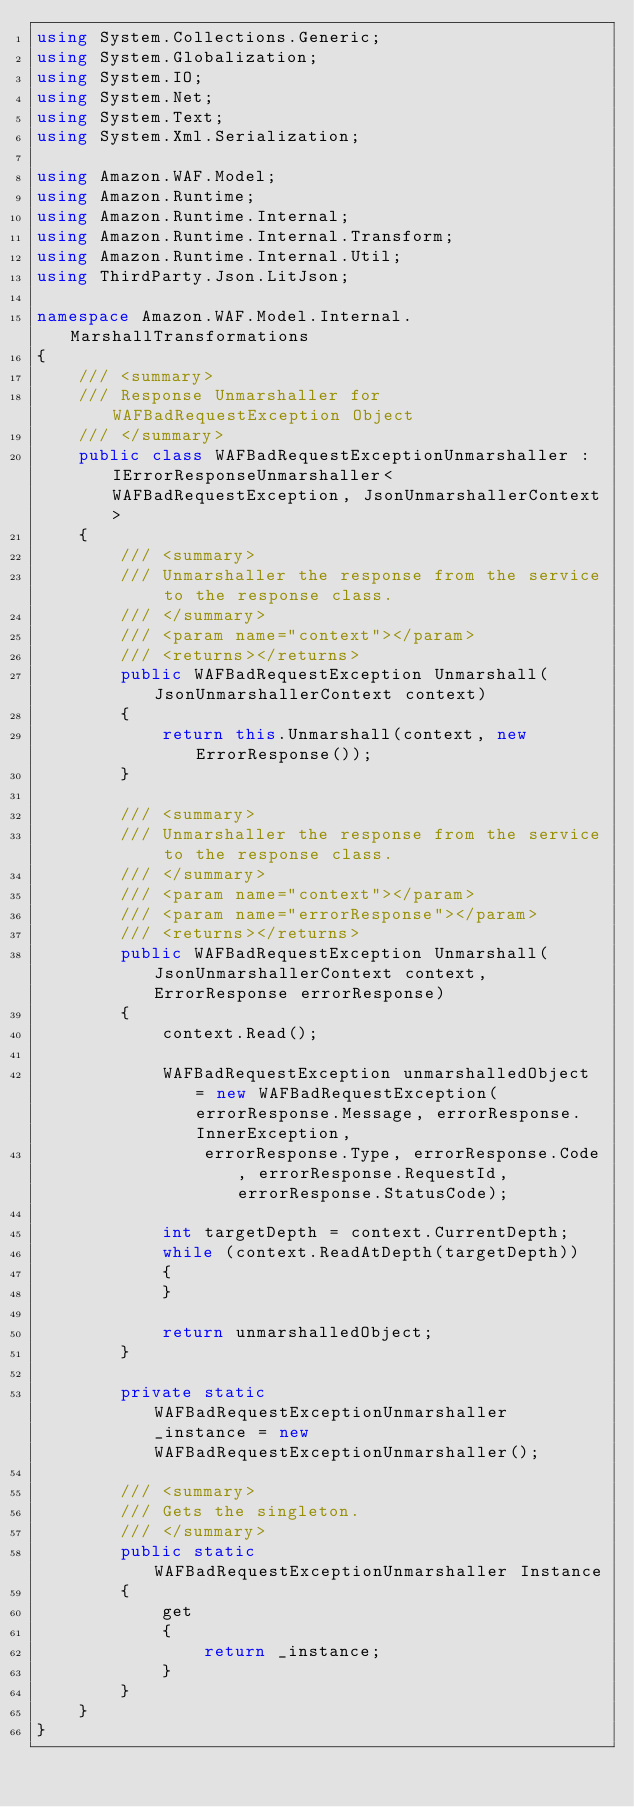Convert code to text. <code><loc_0><loc_0><loc_500><loc_500><_C#_>using System.Collections.Generic;
using System.Globalization;
using System.IO;
using System.Net;
using System.Text;
using System.Xml.Serialization;

using Amazon.WAF.Model;
using Amazon.Runtime;
using Amazon.Runtime.Internal;
using Amazon.Runtime.Internal.Transform;
using Amazon.Runtime.Internal.Util;
using ThirdParty.Json.LitJson;

namespace Amazon.WAF.Model.Internal.MarshallTransformations
{
    /// <summary>
    /// Response Unmarshaller for WAFBadRequestException Object
    /// </summary>  
    public class WAFBadRequestExceptionUnmarshaller : IErrorResponseUnmarshaller<WAFBadRequestException, JsonUnmarshallerContext>
    {
        /// <summary>
        /// Unmarshaller the response from the service to the response class.
        /// </summary>  
        /// <param name="context"></param>
        /// <returns></returns>
        public WAFBadRequestException Unmarshall(JsonUnmarshallerContext context)
        {
            return this.Unmarshall(context, new ErrorResponse());
        }

        /// <summary>
        /// Unmarshaller the response from the service to the response class.
        /// </summary>  
        /// <param name="context"></param>
        /// <param name="errorResponse"></param>
        /// <returns></returns>
        public WAFBadRequestException Unmarshall(JsonUnmarshallerContext context, ErrorResponse errorResponse)
        {
            context.Read();

            WAFBadRequestException unmarshalledObject = new WAFBadRequestException(errorResponse.Message, errorResponse.InnerException,
                errorResponse.Type, errorResponse.Code, errorResponse.RequestId, errorResponse.StatusCode);
        
            int targetDepth = context.CurrentDepth;
            while (context.ReadAtDepth(targetDepth))
            {
            }
          
            return unmarshalledObject;
        }

        private static WAFBadRequestExceptionUnmarshaller _instance = new WAFBadRequestExceptionUnmarshaller();        

        /// <summary>
        /// Gets the singleton.
        /// </summary>  
        public static WAFBadRequestExceptionUnmarshaller Instance
        {
            get
            {
                return _instance;
            }
        }
    }
}</code> 